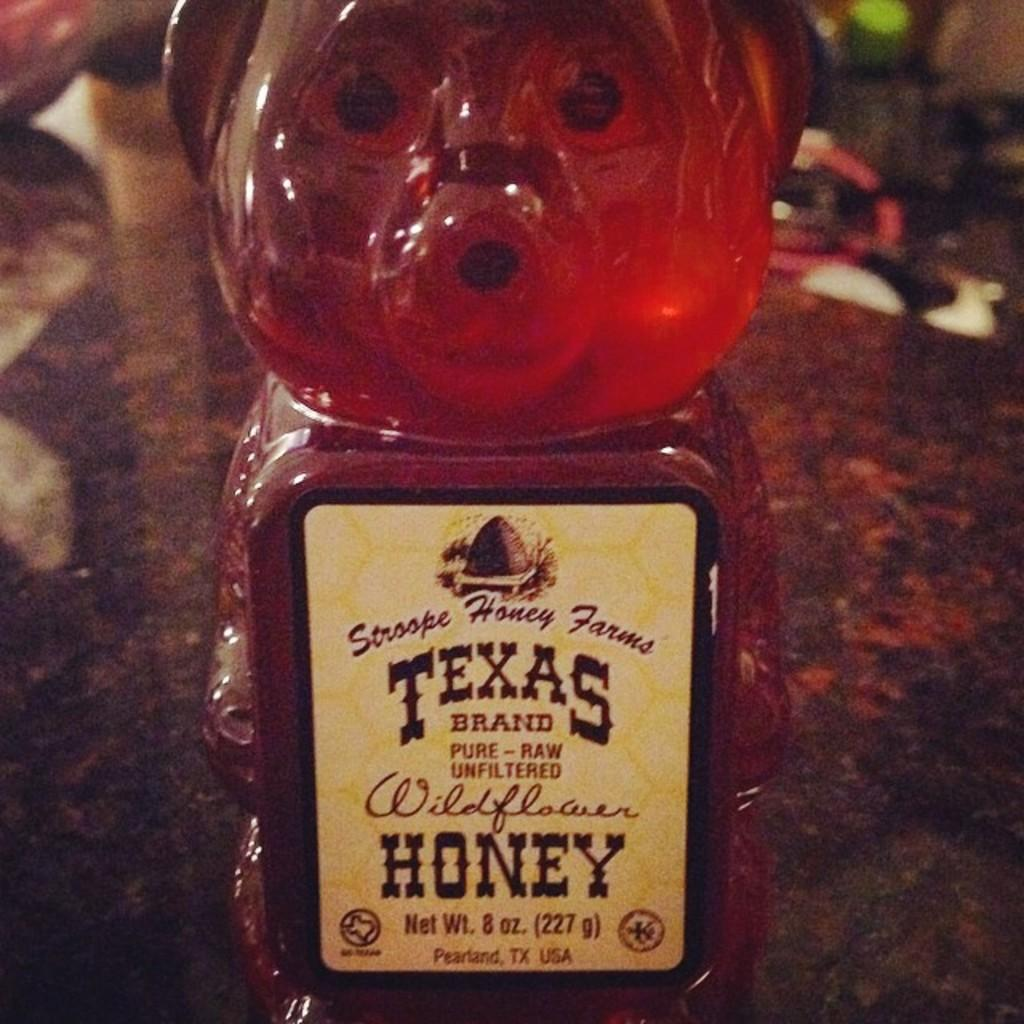What is in the image that contains a liquid? There is a bottle in the image that contains a red color drink. What can be seen on the bottle besides the liquid? The bottle has a label with text on it. Where is the label placed in relation to the bottle? The label is placed on a surface, likely the bottle itself. How would you describe the overall appearance of the image? The background of the image is dark. What type of shoes can be seen rubbing against the bottle in the image? There are no shoes present in the image, and therefore no rubbing against the bottle can be observed. 